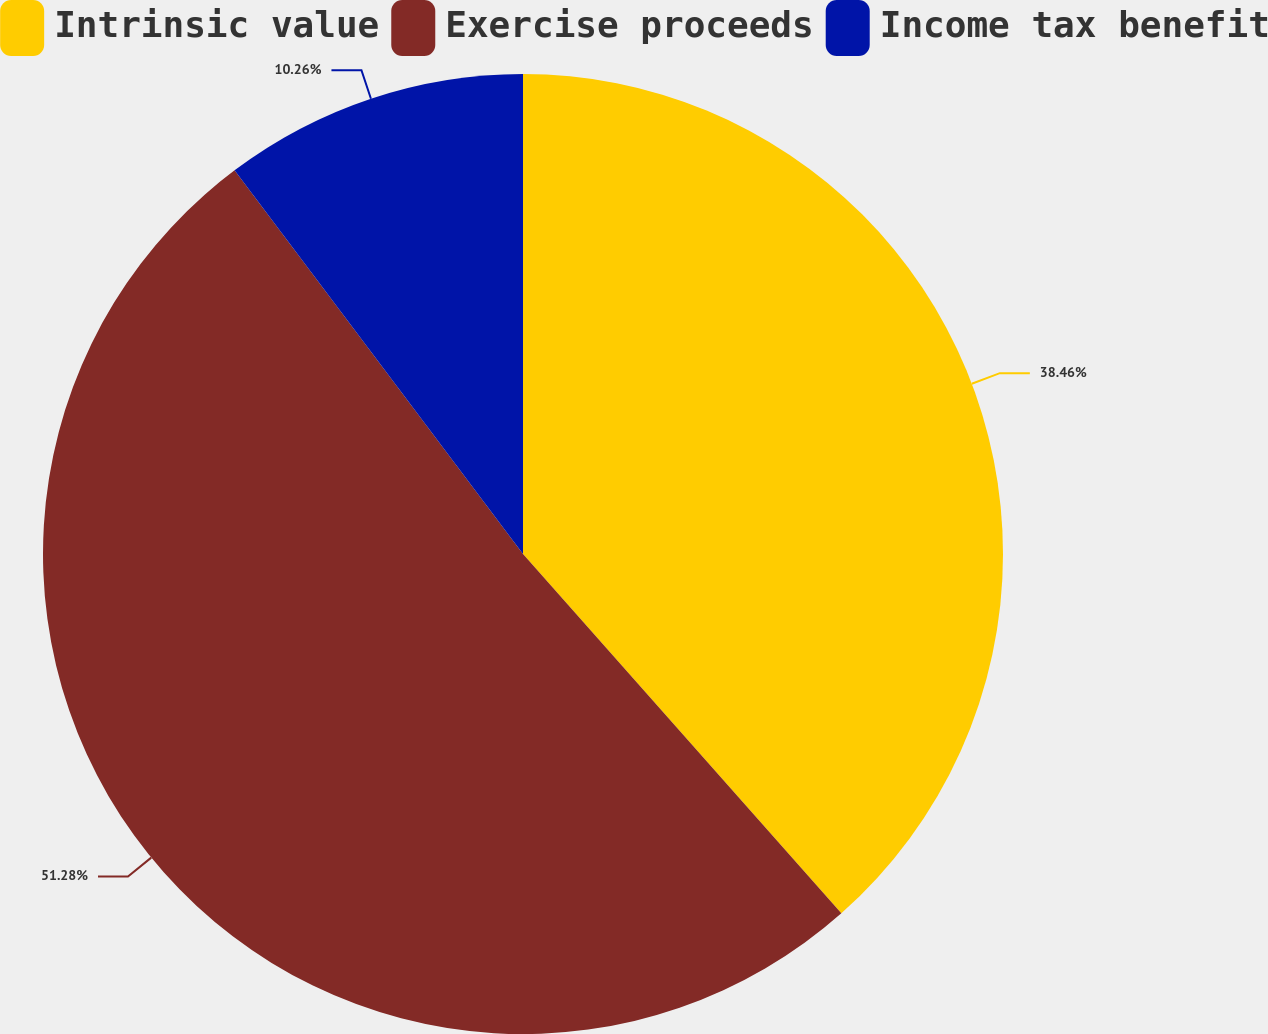<chart> <loc_0><loc_0><loc_500><loc_500><pie_chart><fcel>Intrinsic value<fcel>Exercise proceeds<fcel>Income tax benefit<nl><fcel>38.46%<fcel>51.28%<fcel>10.26%<nl></chart> 